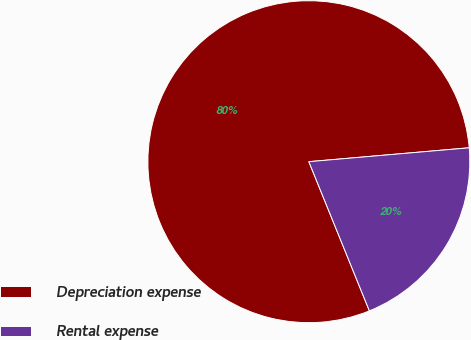Convert chart. <chart><loc_0><loc_0><loc_500><loc_500><pie_chart><fcel>Depreciation expense<fcel>Rental expense<nl><fcel>79.76%<fcel>20.24%<nl></chart> 